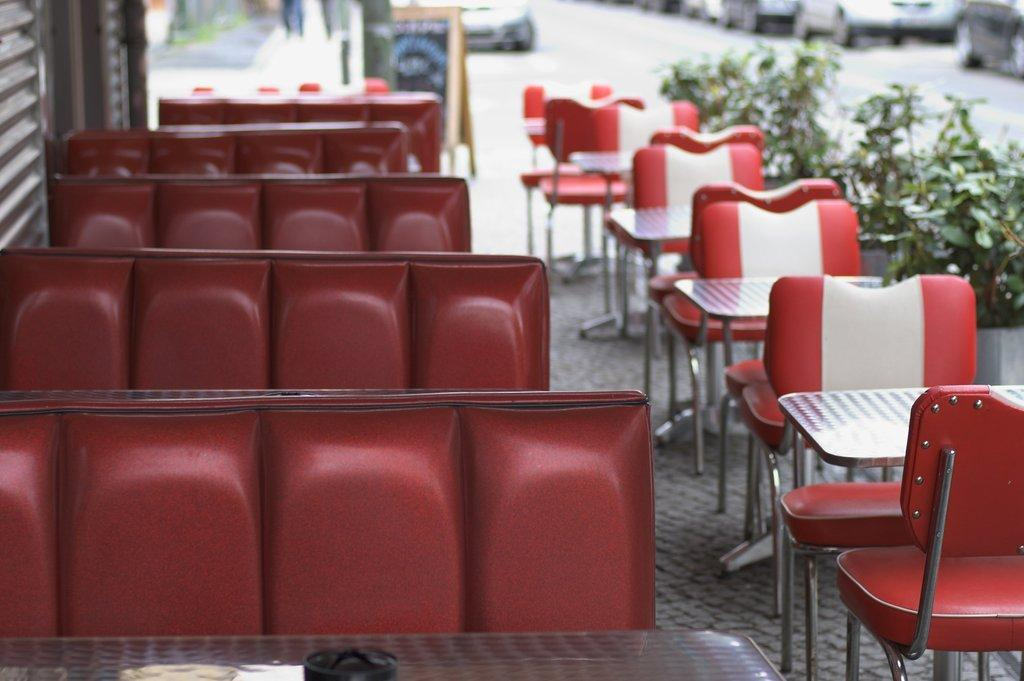What type of furniture is present in the image? There are chairs and tables in the image. Where are the plants located in the image? The plants are on the right side of the image. What else can be seen on the ground in the image? There are vehicles visible on the ground in the image. What type of flag is being waved by the librarian in the image? There is no librarian or flag present in the image. What type of voyage is being depicted in the image? There is no voyage depicted in the image; it features chairs, tables, plants, and vehicles. 